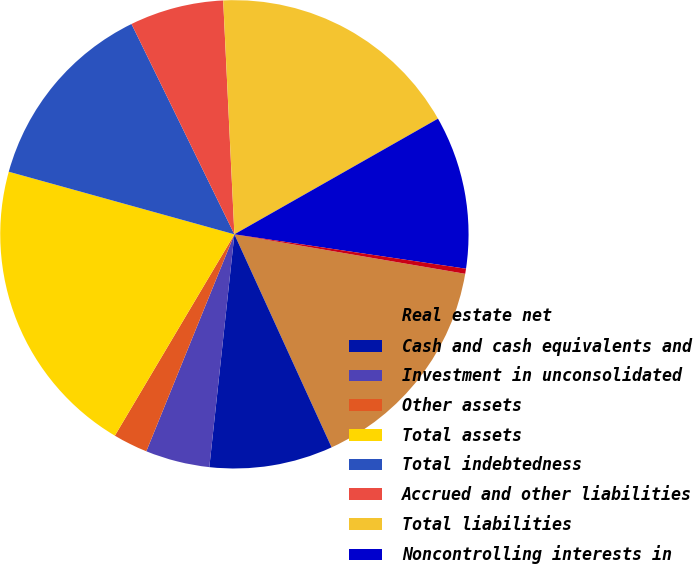Convert chart to OTSL. <chart><loc_0><loc_0><loc_500><loc_500><pie_chart><fcel>Real estate net<fcel>Cash and cash equivalents and<fcel>Investment in unconsolidated<fcel>Other assets<fcel>Total assets<fcel>Total indebtedness<fcel>Accrued and other liabilities<fcel>Total liabilities<fcel>Noncontrolling interests in<fcel>Equity attributable to Aimco<nl><fcel>15.49%<fcel>8.52%<fcel>4.43%<fcel>2.39%<fcel>20.78%<fcel>13.45%<fcel>6.48%<fcel>17.54%<fcel>10.57%<fcel>0.35%<nl></chart> 